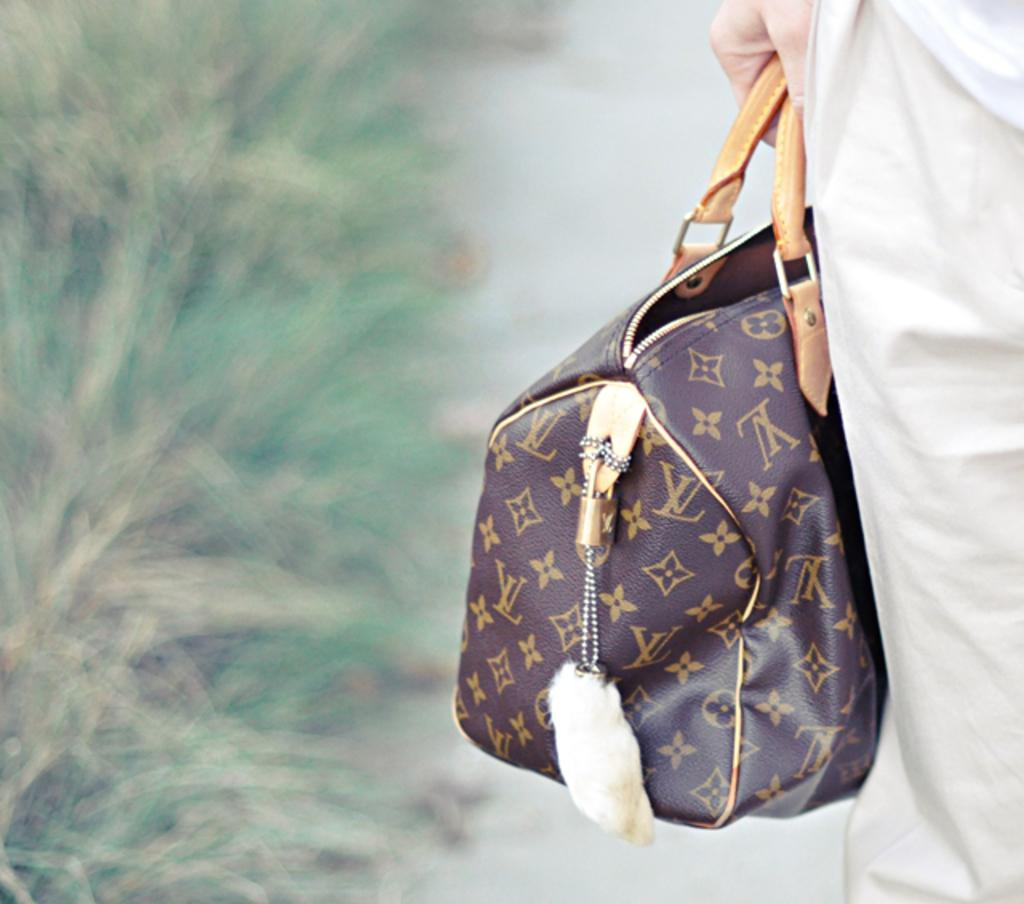What is present in the image? There is a person in the image. What is the person holding in their hand? The person is holding a bag in their hand. What type of glove is the person wearing in the image? There is no glove present in the image; the person is holding a bag. What type of work is the slave performing in the image? There is no mention of a slave or any work being performed in the image; it only shows a person holding a bag. 